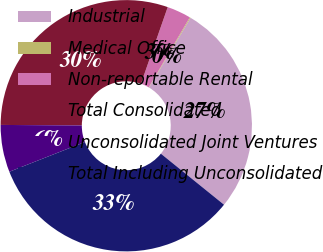Convert chart. <chart><loc_0><loc_0><loc_500><loc_500><pie_chart><fcel>Industrial<fcel>Medical Office<fcel>Non-reportable Rental<fcel>Total Consolidated<fcel>Unconsolidated Joint Ventures<fcel>Total Including Unconsolidated<nl><fcel>27.27%<fcel>0.11%<fcel>3.09%<fcel>30.25%<fcel>6.07%<fcel>33.22%<nl></chart> 